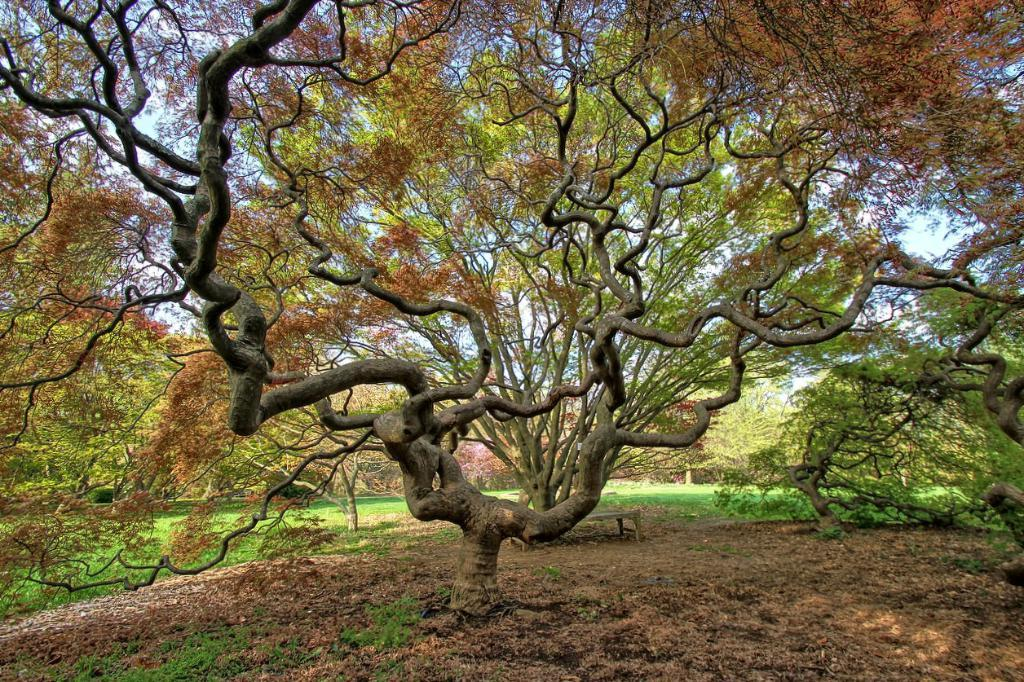What type of vegetation can be seen in the image? There are trees in the image. Where are the trees located? The trees are on a grassland. Can you see a monkey using a toothbrush in the image? There is no monkey or toothbrush present in the image. 